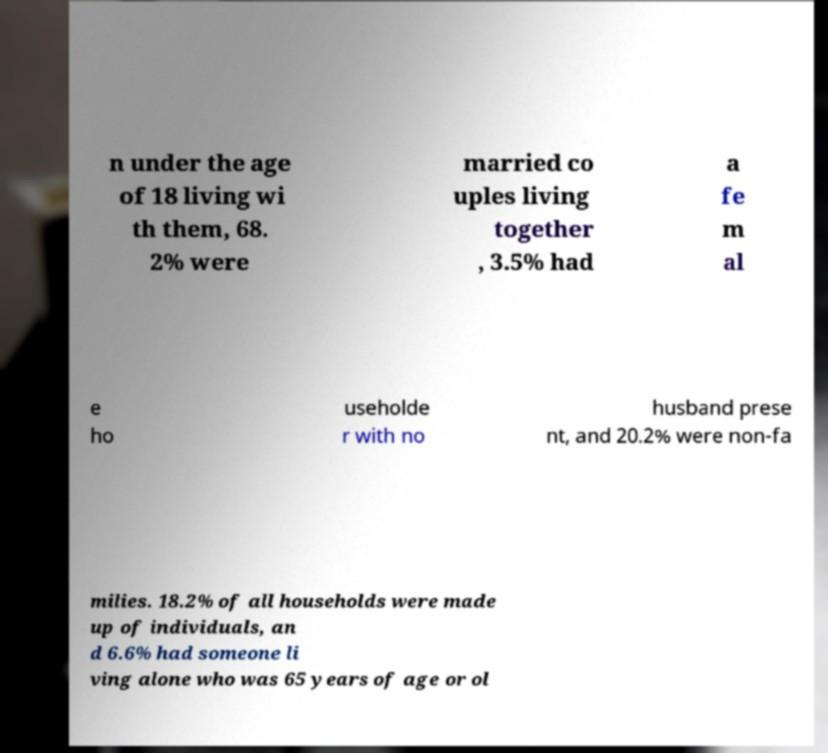Could you assist in decoding the text presented in this image and type it out clearly? n under the age of 18 living wi th them, 68. 2% were married co uples living together , 3.5% had a fe m al e ho useholde r with no husband prese nt, and 20.2% were non-fa milies. 18.2% of all households were made up of individuals, an d 6.6% had someone li ving alone who was 65 years of age or ol 